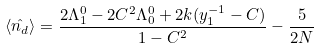Convert formula to latex. <formula><loc_0><loc_0><loc_500><loc_500>\langle \hat { n _ { d } } \rangle = \frac { 2 \Lambda _ { 1 } ^ { 0 } - 2 C ^ { 2 } \Lambda _ { 0 } ^ { 0 } + 2 k ( y _ { 1 } ^ { - 1 } - C ) } { 1 - C ^ { 2 } } - \frac { 5 } { 2 N }</formula> 